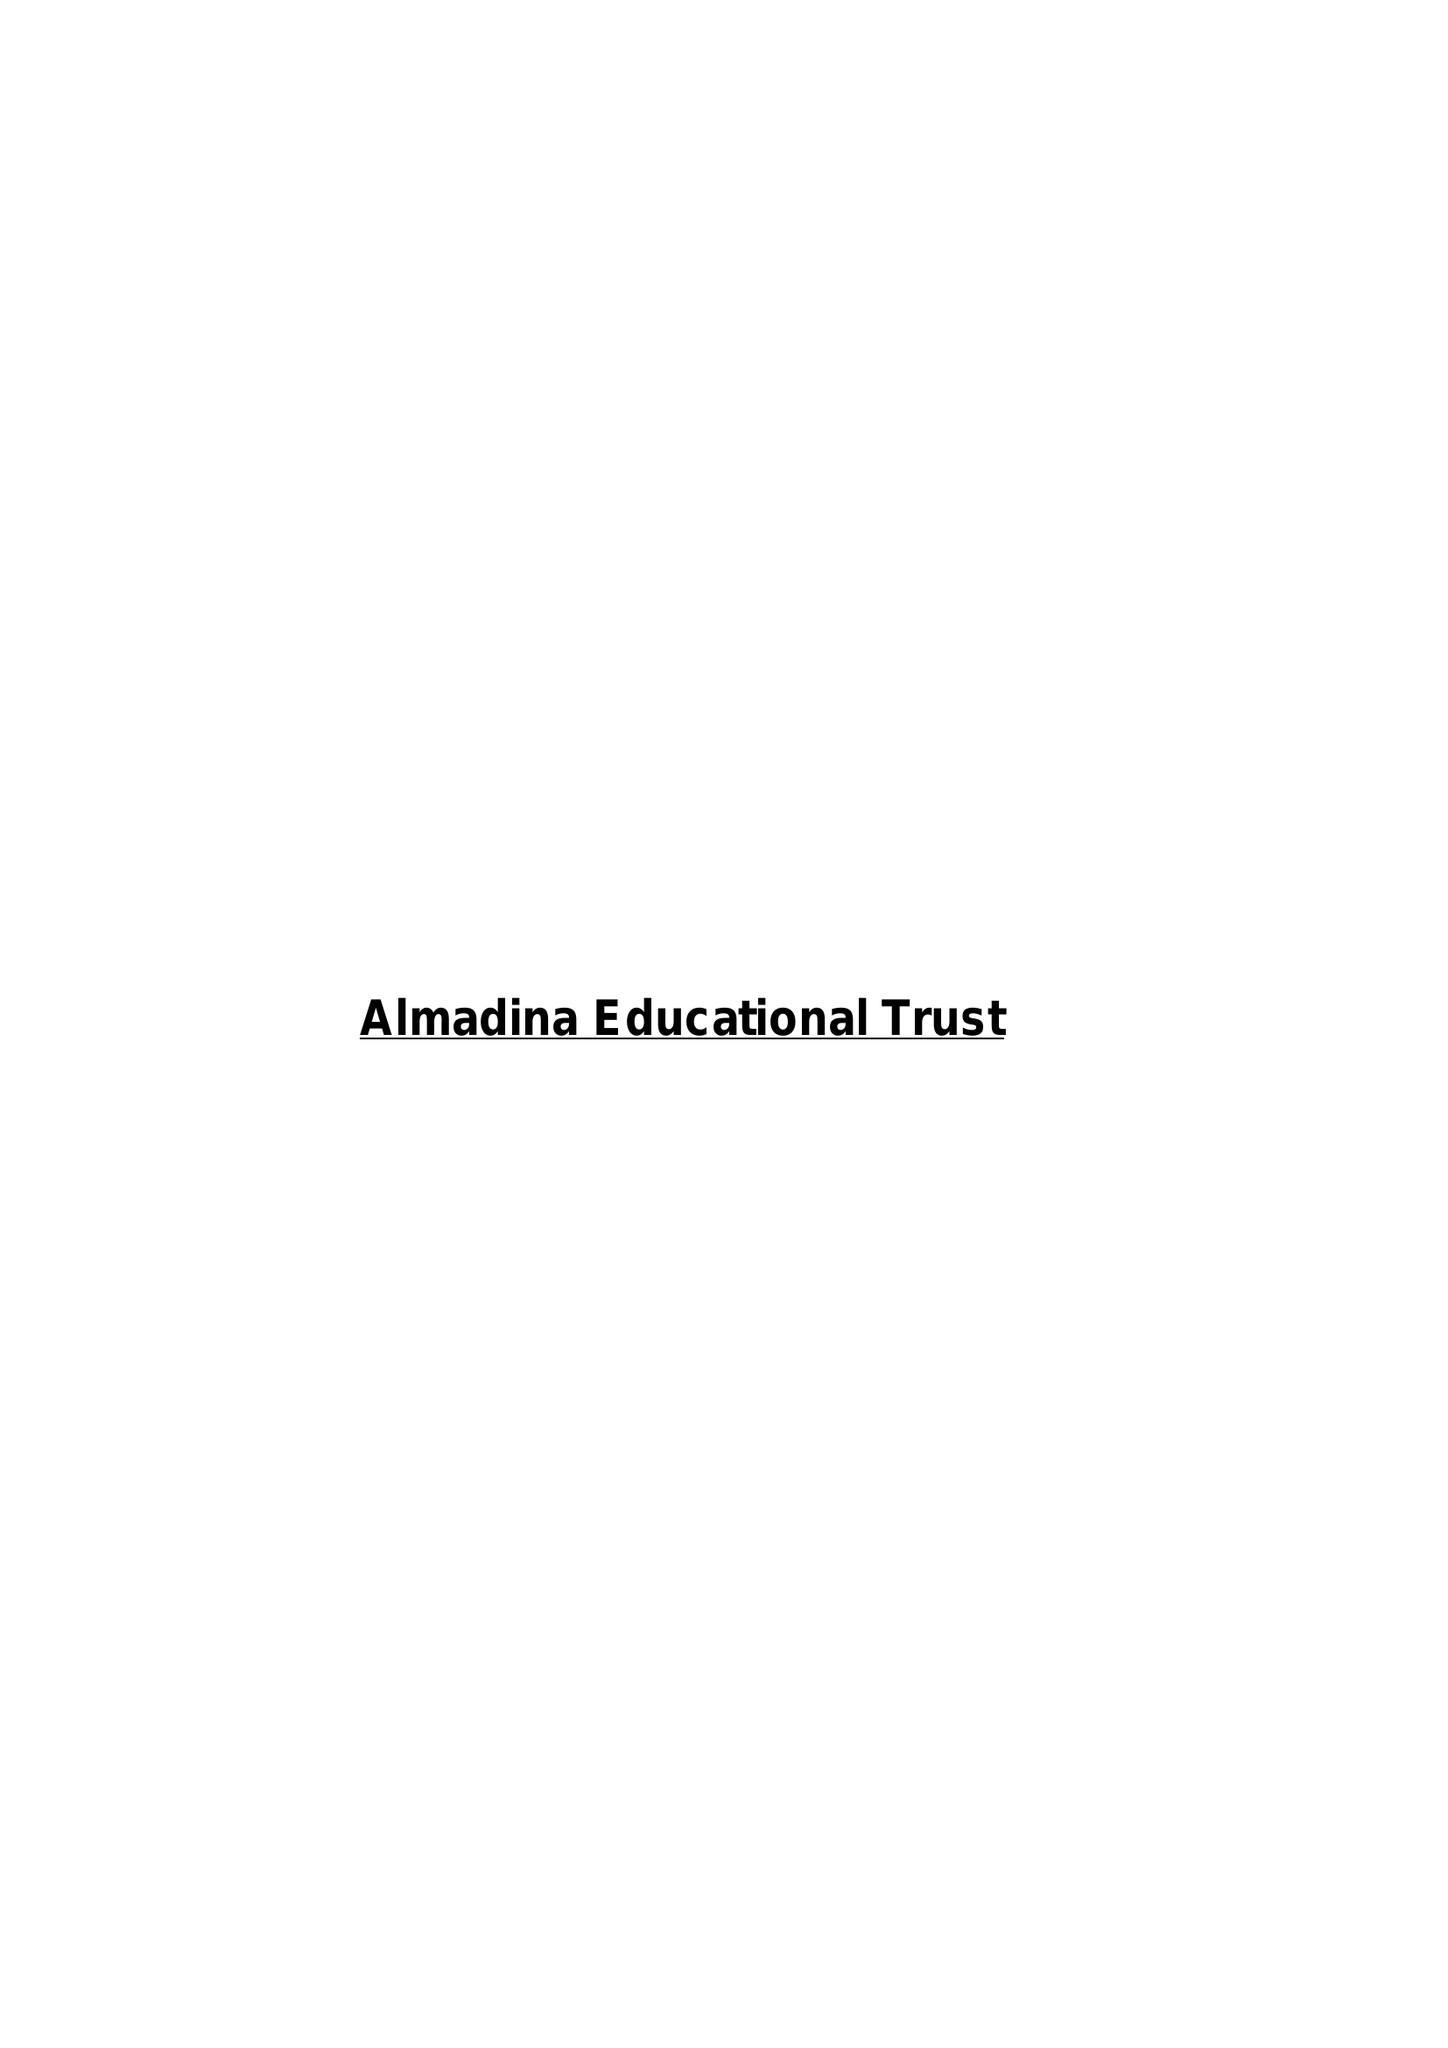What is the value for the charity_name?
Answer the question using a single word or phrase. Almadina Educational Trust 